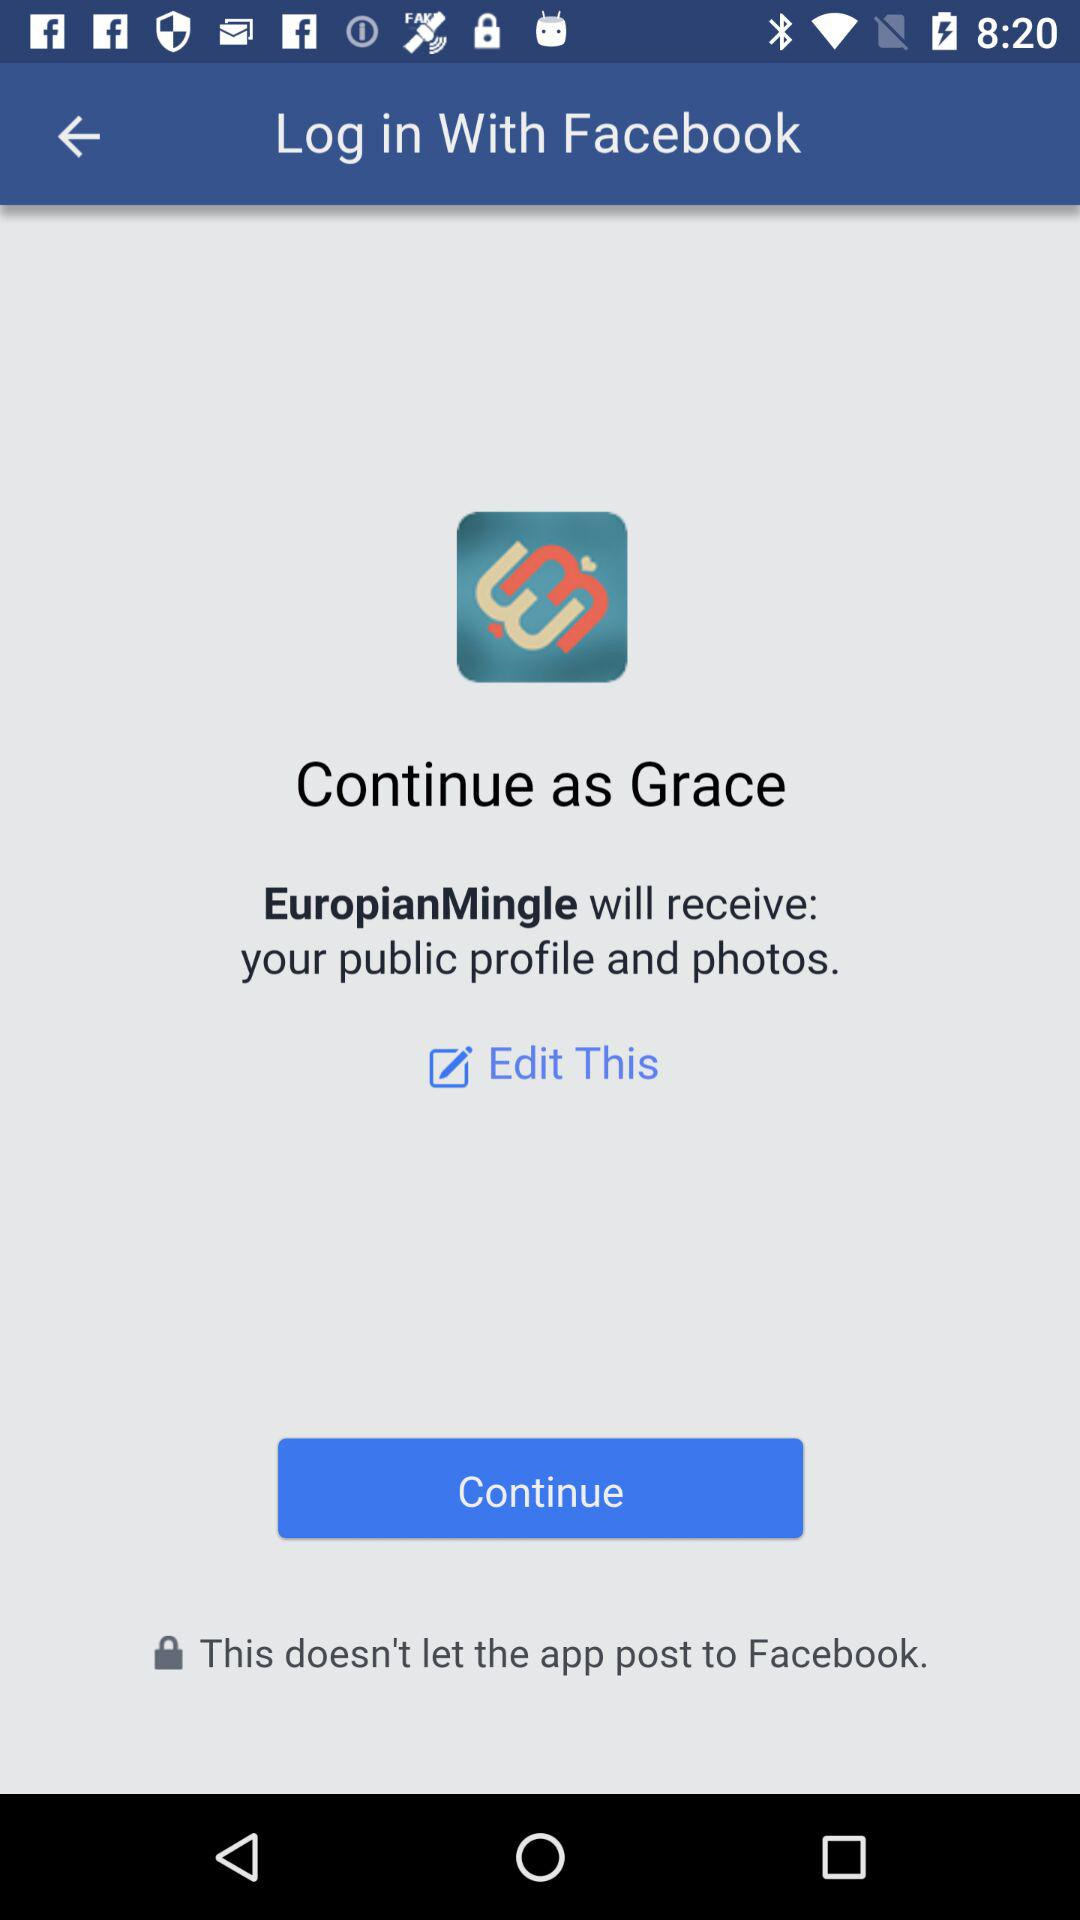Which application are we accessing? The application you are accessing is "EuropianMingle". 